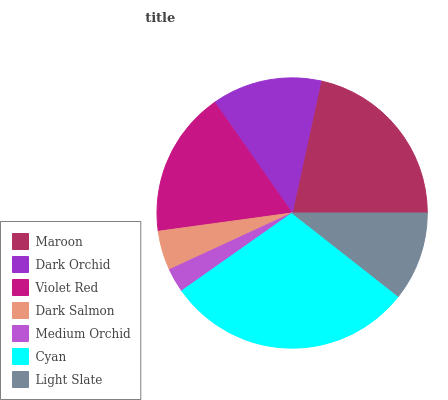Is Medium Orchid the minimum?
Answer yes or no. Yes. Is Cyan the maximum?
Answer yes or no. Yes. Is Dark Orchid the minimum?
Answer yes or no. No. Is Dark Orchid the maximum?
Answer yes or no. No. Is Maroon greater than Dark Orchid?
Answer yes or no. Yes. Is Dark Orchid less than Maroon?
Answer yes or no. Yes. Is Dark Orchid greater than Maroon?
Answer yes or no. No. Is Maroon less than Dark Orchid?
Answer yes or no. No. Is Dark Orchid the high median?
Answer yes or no. Yes. Is Dark Orchid the low median?
Answer yes or no. Yes. Is Light Slate the high median?
Answer yes or no. No. Is Light Slate the low median?
Answer yes or no. No. 